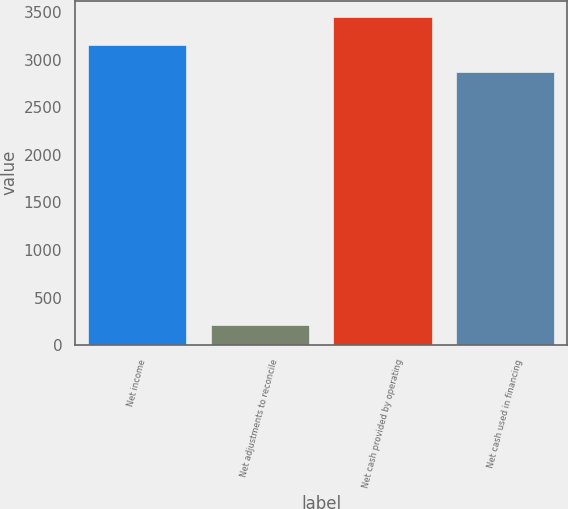<chart> <loc_0><loc_0><loc_500><loc_500><bar_chart><fcel>Net income<fcel>Net adjustments to reconcile<fcel>Net cash provided by operating<fcel>Net cash used in financing<nl><fcel>3160.4<fcel>214<fcel>3452.8<fcel>2868<nl></chart> 